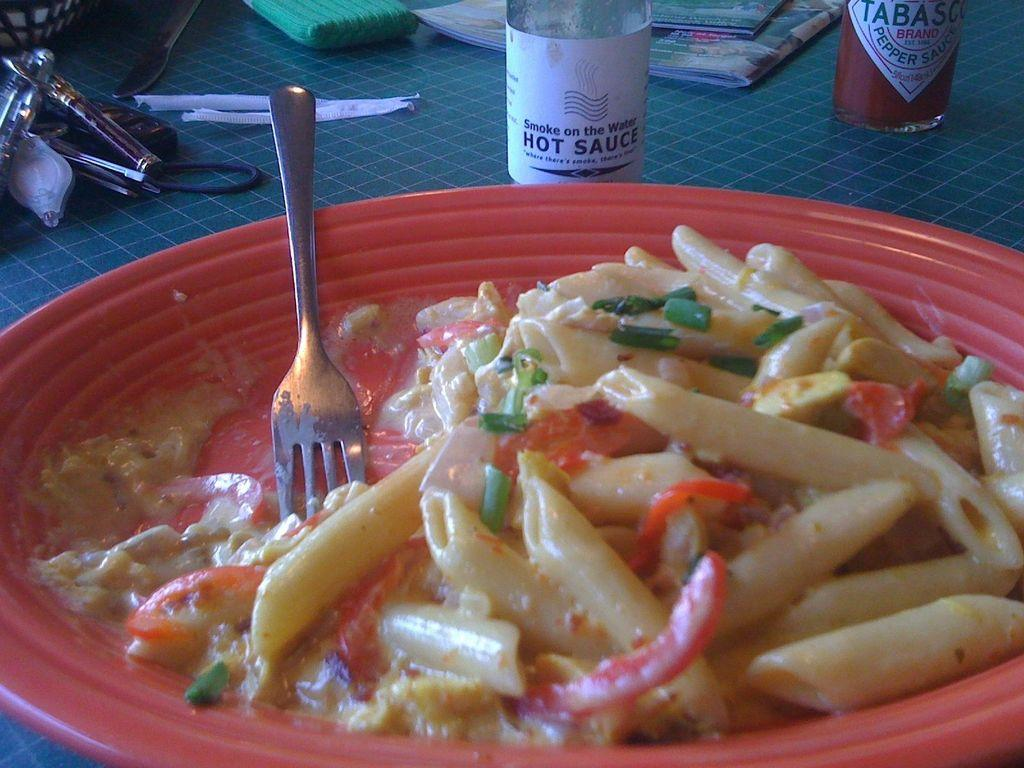What type of food is on the plate in the image? There is a plate of white sauce pasta in the image. What utensil is visible in the image? A fork is visible in the image. What condiment can be seen in the background of the image? There is hot sauce in the background of the image. Can you describe any other items visible in the background? There are other unspecified items in the background of the image. What government policy is being discussed in the image? There is no indication of a government policy or discussion in the image; it primarily features a plate of white sauce pasta and related items. 